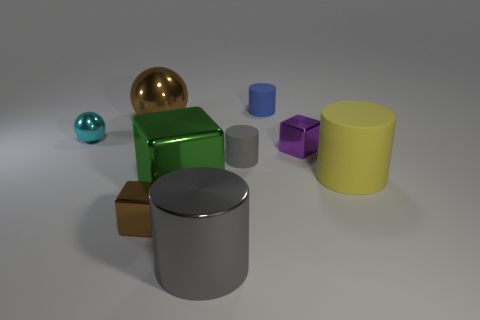Are there any big metal objects that have the same color as the metallic cylinder?
Provide a short and direct response. No. There is a metal thing that is left of the brown object that is behind the small metal cube that is in front of the big green metal block; what is its shape?
Ensure brevity in your answer.  Sphere. What is the cylinder that is in front of the big matte cylinder made of?
Keep it short and to the point. Metal. There is a green metal cube that is to the right of the small thing to the left of the small cube that is on the left side of the large green metallic thing; what is its size?
Your answer should be compact. Large. There is a yellow thing; does it have the same size as the block behind the big shiny cube?
Keep it short and to the point. No. There is a cylinder that is left of the gray matte cylinder; what is its color?
Your answer should be compact. Gray. What shape is the thing that is the same color as the big sphere?
Offer a terse response. Cube. What shape is the tiny matte object behind the small metallic sphere?
Your response must be concise. Cylinder. What number of gray objects are either small blocks or tiny metallic spheres?
Keep it short and to the point. 0. Do the large brown thing and the small brown cube have the same material?
Your answer should be compact. Yes. 